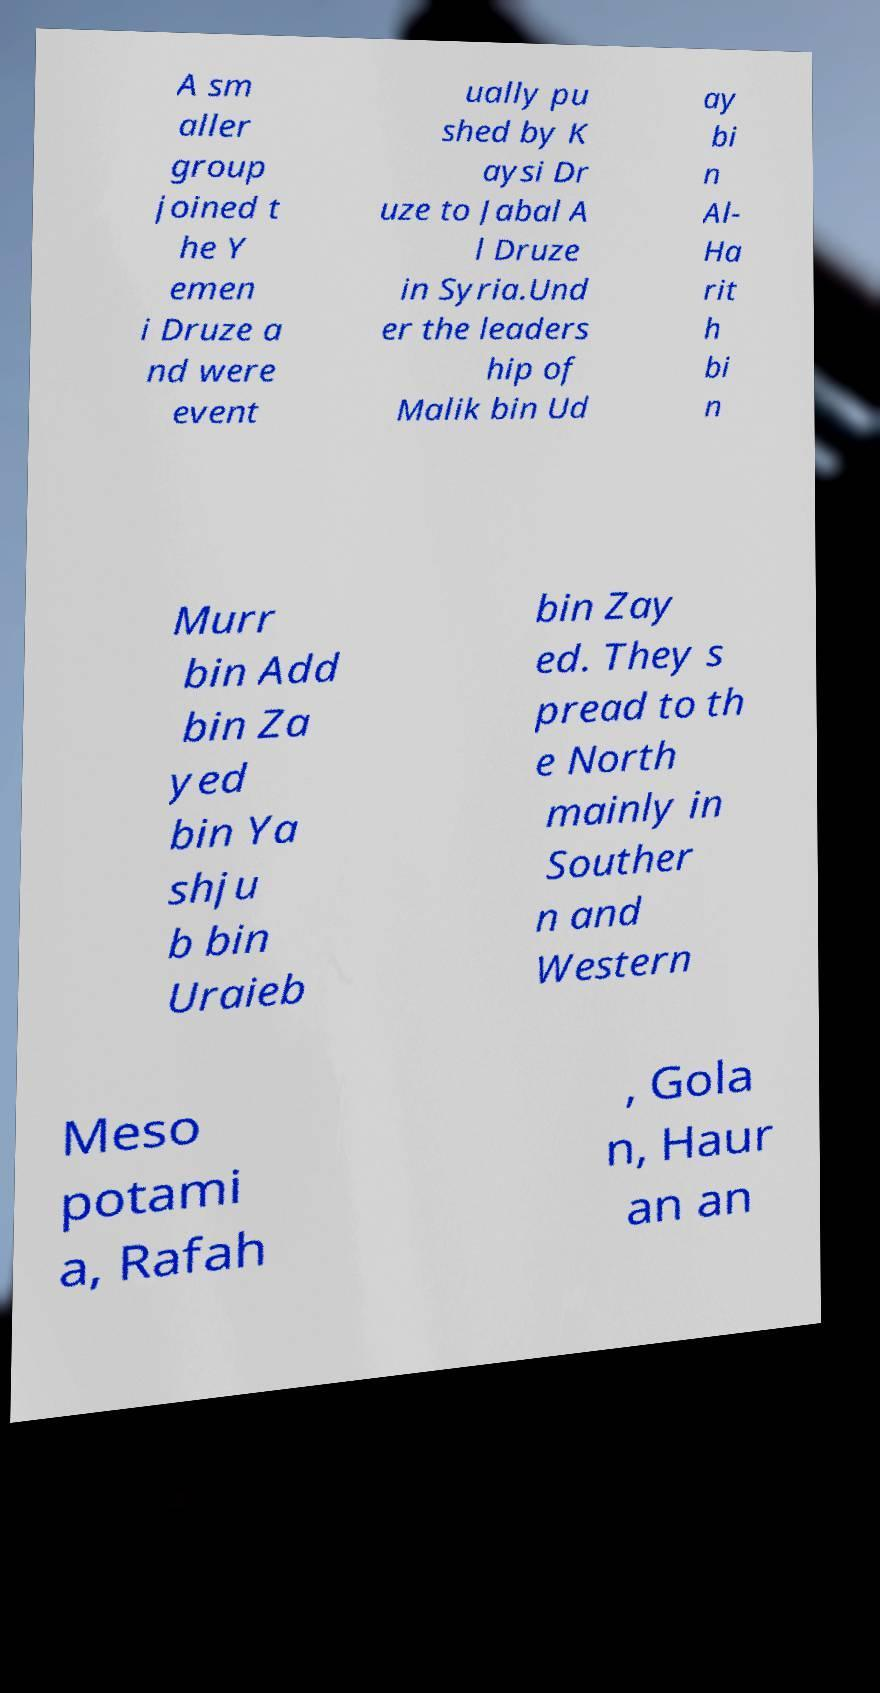There's text embedded in this image that I need extracted. Can you transcribe it verbatim? A sm aller group joined t he Y emen i Druze a nd were event ually pu shed by K aysi Dr uze to Jabal A l Druze in Syria.Und er the leaders hip of Malik bin Ud ay bi n Al- Ha rit h bi n Murr bin Add bin Za yed bin Ya shju b bin Uraieb bin Zay ed. They s pread to th e North mainly in Souther n and Western Meso potami a, Rafah , Gola n, Haur an an 